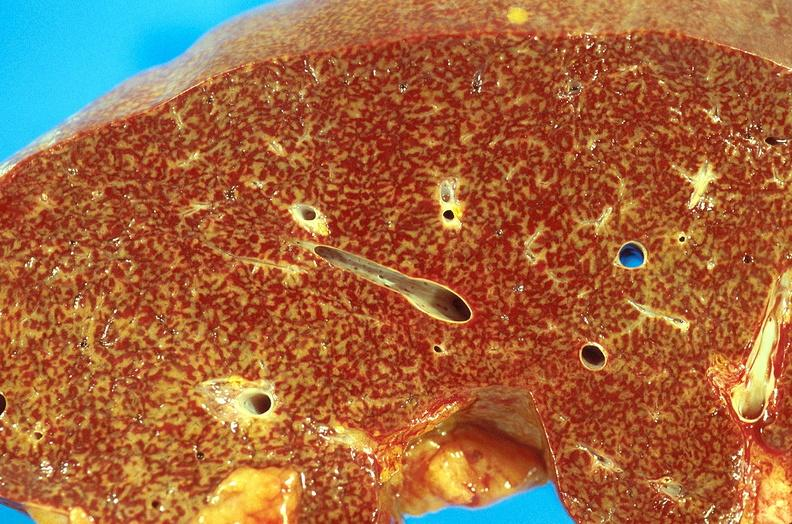what is present?
Answer the question using a single word or phrase. Hepatobiliary 